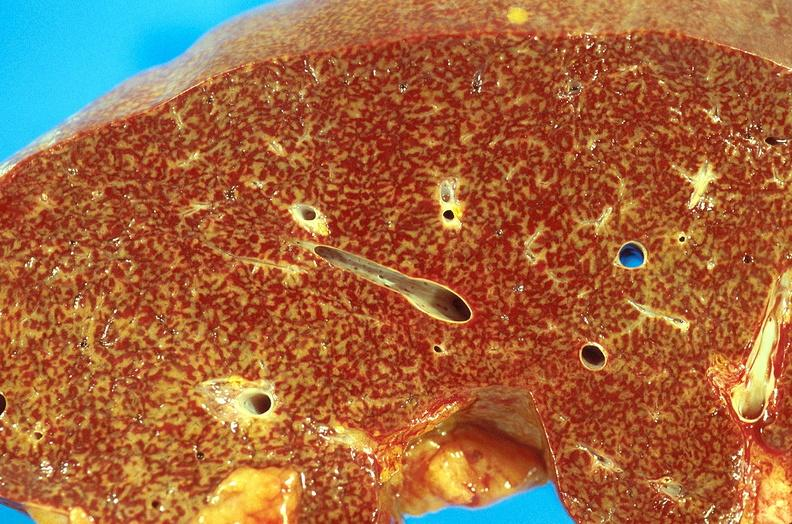what is present?
Answer the question using a single word or phrase. Hepatobiliary 